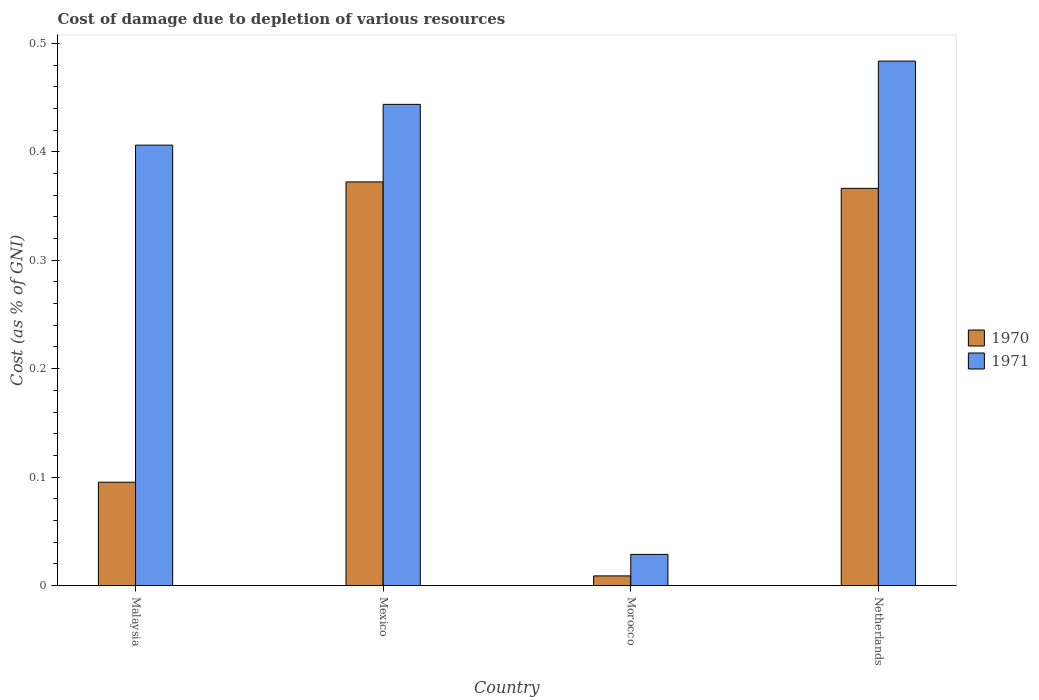How many different coloured bars are there?
Your response must be concise. 2. What is the label of the 3rd group of bars from the left?
Ensure brevity in your answer.  Morocco. What is the cost of damage caused due to the depletion of various resources in 1970 in Netherlands?
Your response must be concise. 0.37. Across all countries, what is the maximum cost of damage caused due to the depletion of various resources in 1971?
Ensure brevity in your answer.  0.48. Across all countries, what is the minimum cost of damage caused due to the depletion of various resources in 1970?
Keep it short and to the point. 0.01. In which country was the cost of damage caused due to the depletion of various resources in 1971 minimum?
Give a very brief answer. Morocco. What is the total cost of damage caused due to the depletion of various resources in 1970 in the graph?
Ensure brevity in your answer.  0.84. What is the difference between the cost of damage caused due to the depletion of various resources in 1971 in Mexico and that in Morocco?
Provide a short and direct response. 0.41. What is the difference between the cost of damage caused due to the depletion of various resources in 1970 in Morocco and the cost of damage caused due to the depletion of various resources in 1971 in Malaysia?
Offer a terse response. -0.4. What is the average cost of damage caused due to the depletion of various resources in 1970 per country?
Ensure brevity in your answer.  0.21. What is the difference between the cost of damage caused due to the depletion of various resources of/in 1970 and cost of damage caused due to the depletion of various resources of/in 1971 in Morocco?
Your response must be concise. -0.02. In how many countries, is the cost of damage caused due to the depletion of various resources in 1970 greater than 0.18 %?
Provide a short and direct response. 2. What is the ratio of the cost of damage caused due to the depletion of various resources in 1971 in Malaysia to that in Mexico?
Make the answer very short. 0.92. Is the difference between the cost of damage caused due to the depletion of various resources in 1970 in Mexico and Morocco greater than the difference between the cost of damage caused due to the depletion of various resources in 1971 in Mexico and Morocco?
Your response must be concise. No. What is the difference between the highest and the second highest cost of damage caused due to the depletion of various resources in 1970?
Your answer should be compact. 0.28. What is the difference between the highest and the lowest cost of damage caused due to the depletion of various resources in 1971?
Ensure brevity in your answer.  0.45. Is the sum of the cost of damage caused due to the depletion of various resources in 1970 in Malaysia and Netherlands greater than the maximum cost of damage caused due to the depletion of various resources in 1971 across all countries?
Provide a short and direct response. No. What does the 2nd bar from the left in Netherlands represents?
Provide a short and direct response. 1971. How many bars are there?
Your answer should be very brief. 8. How many countries are there in the graph?
Your response must be concise. 4. Does the graph contain any zero values?
Your answer should be compact. No. Does the graph contain grids?
Ensure brevity in your answer.  No. Where does the legend appear in the graph?
Offer a very short reply. Center right. How are the legend labels stacked?
Your answer should be compact. Vertical. What is the title of the graph?
Your response must be concise. Cost of damage due to depletion of various resources. Does "2000" appear as one of the legend labels in the graph?
Keep it short and to the point. No. What is the label or title of the X-axis?
Provide a succinct answer. Country. What is the label or title of the Y-axis?
Offer a very short reply. Cost (as % of GNI). What is the Cost (as % of GNI) of 1970 in Malaysia?
Offer a very short reply. 0.1. What is the Cost (as % of GNI) in 1971 in Malaysia?
Your answer should be very brief. 0.41. What is the Cost (as % of GNI) in 1970 in Mexico?
Ensure brevity in your answer.  0.37. What is the Cost (as % of GNI) in 1971 in Mexico?
Provide a succinct answer. 0.44. What is the Cost (as % of GNI) in 1970 in Morocco?
Your answer should be very brief. 0.01. What is the Cost (as % of GNI) of 1971 in Morocco?
Your answer should be very brief. 0.03. What is the Cost (as % of GNI) of 1970 in Netherlands?
Your response must be concise. 0.37. What is the Cost (as % of GNI) in 1971 in Netherlands?
Ensure brevity in your answer.  0.48. Across all countries, what is the maximum Cost (as % of GNI) of 1970?
Provide a short and direct response. 0.37. Across all countries, what is the maximum Cost (as % of GNI) in 1971?
Ensure brevity in your answer.  0.48. Across all countries, what is the minimum Cost (as % of GNI) of 1970?
Your response must be concise. 0.01. Across all countries, what is the minimum Cost (as % of GNI) in 1971?
Offer a terse response. 0.03. What is the total Cost (as % of GNI) of 1970 in the graph?
Your answer should be compact. 0.84. What is the total Cost (as % of GNI) in 1971 in the graph?
Give a very brief answer. 1.36. What is the difference between the Cost (as % of GNI) in 1970 in Malaysia and that in Mexico?
Offer a very short reply. -0.28. What is the difference between the Cost (as % of GNI) in 1971 in Malaysia and that in Mexico?
Your answer should be compact. -0.04. What is the difference between the Cost (as % of GNI) of 1970 in Malaysia and that in Morocco?
Your response must be concise. 0.09. What is the difference between the Cost (as % of GNI) in 1971 in Malaysia and that in Morocco?
Your answer should be very brief. 0.38. What is the difference between the Cost (as % of GNI) in 1970 in Malaysia and that in Netherlands?
Your answer should be very brief. -0.27. What is the difference between the Cost (as % of GNI) of 1971 in Malaysia and that in Netherlands?
Keep it short and to the point. -0.08. What is the difference between the Cost (as % of GNI) of 1970 in Mexico and that in Morocco?
Ensure brevity in your answer.  0.36. What is the difference between the Cost (as % of GNI) of 1971 in Mexico and that in Morocco?
Provide a succinct answer. 0.41. What is the difference between the Cost (as % of GNI) in 1970 in Mexico and that in Netherlands?
Your answer should be compact. 0.01. What is the difference between the Cost (as % of GNI) of 1971 in Mexico and that in Netherlands?
Make the answer very short. -0.04. What is the difference between the Cost (as % of GNI) of 1970 in Morocco and that in Netherlands?
Make the answer very short. -0.36. What is the difference between the Cost (as % of GNI) of 1971 in Morocco and that in Netherlands?
Provide a succinct answer. -0.45. What is the difference between the Cost (as % of GNI) in 1970 in Malaysia and the Cost (as % of GNI) in 1971 in Mexico?
Provide a short and direct response. -0.35. What is the difference between the Cost (as % of GNI) of 1970 in Malaysia and the Cost (as % of GNI) of 1971 in Morocco?
Your answer should be very brief. 0.07. What is the difference between the Cost (as % of GNI) of 1970 in Malaysia and the Cost (as % of GNI) of 1971 in Netherlands?
Offer a very short reply. -0.39. What is the difference between the Cost (as % of GNI) in 1970 in Mexico and the Cost (as % of GNI) in 1971 in Morocco?
Offer a terse response. 0.34. What is the difference between the Cost (as % of GNI) in 1970 in Mexico and the Cost (as % of GNI) in 1971 in Netherlands?
Make the answer very short. -0.11. What is the difference between the Cost (as % of GNI) of 1970 in Morocco and the Cost (as % of GNI) of 1971 in Netherlands?
Provide a succinct answer. -0.47. What is the average Cost (as % of GNI) of 1970 per country?
Provide a short and direct response. 0.21. What is the average Cost (as % of GNI) of 1971 per country?
Your answer should be very brief. 0.34. What is the difference between the Cost (as % of GNI) in 1970 and Cost (as % of GNI) in 1971 in Malaysia?
Keep it short and to the point. -0.31. What is the difference between the Cost (as % of GNI) in 1970 and Cost (as % of GNI) in 1971 in Mexico?
Your answer should be very brief. -0.07. What is the difference between the Cost (as % of GNI) in 1970 and Cost (as % of GNI) in 1971 in Morocco?
Your response must be concise. -0.02. What is the difference between the Cost (as % of GNI) of 1970 and Cost (as % of GNI) of 1971 in Netherlands?
Your answer should be very brief. -0.12. What is the ratio of the Cost (as % of GNI) of 1970 in Malaysia to that in Mexico?
Provide a succinct answer. 0.26. What is the ratio of the Cost (as % of GNI) of 1971 in Malaysia to that in Mexico?
Ensure brevity in your answer.  0.92. What is the ratio of the Cost (as % of GNI) of 1970 in Malaysia to that in Morocco?
Keep it short and to the point. 10.69. What is the ratio of the Cost (as % of GNI) in 1971 in Malaysia to that in Morocco?
Make the answer very short. 14.13. What is the ratio of the Cost (as % of GNI) in 1970 in Malaysia to that in Netherlands?
Provide a succinct answer. 0.26. What is the ratio of the Cost (as % of GNI) of 1971 in Malaysia to that in Netherlands?
Make the answer very short. 0.84. What is the ratio of the Cost (as % of GNI) in 1970 in Mexico to that in Morocco?
Your answer should be compact. 41.78. What is the ratio of the Cost (as % of GNI) in 1971 in Mexico to that in Morocco?
Ensure brevity in your answer.  15.44. What is the ratio of the Cost (as % of GNI) of 1970 in Mexico to that in Netherlands?
Keep it short and to the point. 1.02. What is the ratio of the Cost (as % of GNI) in 1971 in Mexico to that in Netherlands?
Offer a very short reply. 0.92. What is the ratio of the Cost (as % of GNI) of 1970 in Morocco to that in Netherlands?
Ensure brevity in your answer.  0.02. What is the ratio of the Cost (as % of GNI) in 1971 in Morocco to that in Netherlands?
Offer a terse response. 0.06. What is the difference between the highest and the second highest Cost (as % of GNI) in 1970?
Offer a very short reply. 0.01. What is the difference between the highest and the second highest Cost (as % of GNI) in 1971?
Your answer should be very brief. 0.04. What is the difference between the highest and the lowest Cost (as % of GNI) of 1970?
Your answer should be very brief. 0.36. What is the difference between the highest and the lowest Cost (as % of GNI) of 1971?
Offer a terse response. 0.45. 